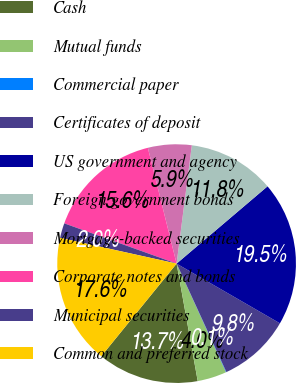Convert chart. <chart><loc_0><loc_0><loc_500><loc_500><pie_chart><fcel>Cash<fcel>Mutual funds<fcel>Commercial paper<fcel>Certificates of deposit<fcel>US government and agency<fcel>Foreign government bonds<fcel>Mortgage-backed securities<fcel>Corporate notes and bonds<fcel>Municipal securities<fcel>Common and preferred stock<nl><fcel>13.7%<fcel>3.96%<fcel>0.06%<fcel>9.81%<fcel>19.55%<fcel>11.75%<fcel>5.91%<fcel>15.65%<fcel>2.01%<fcel>17.6%<nl></chart> 